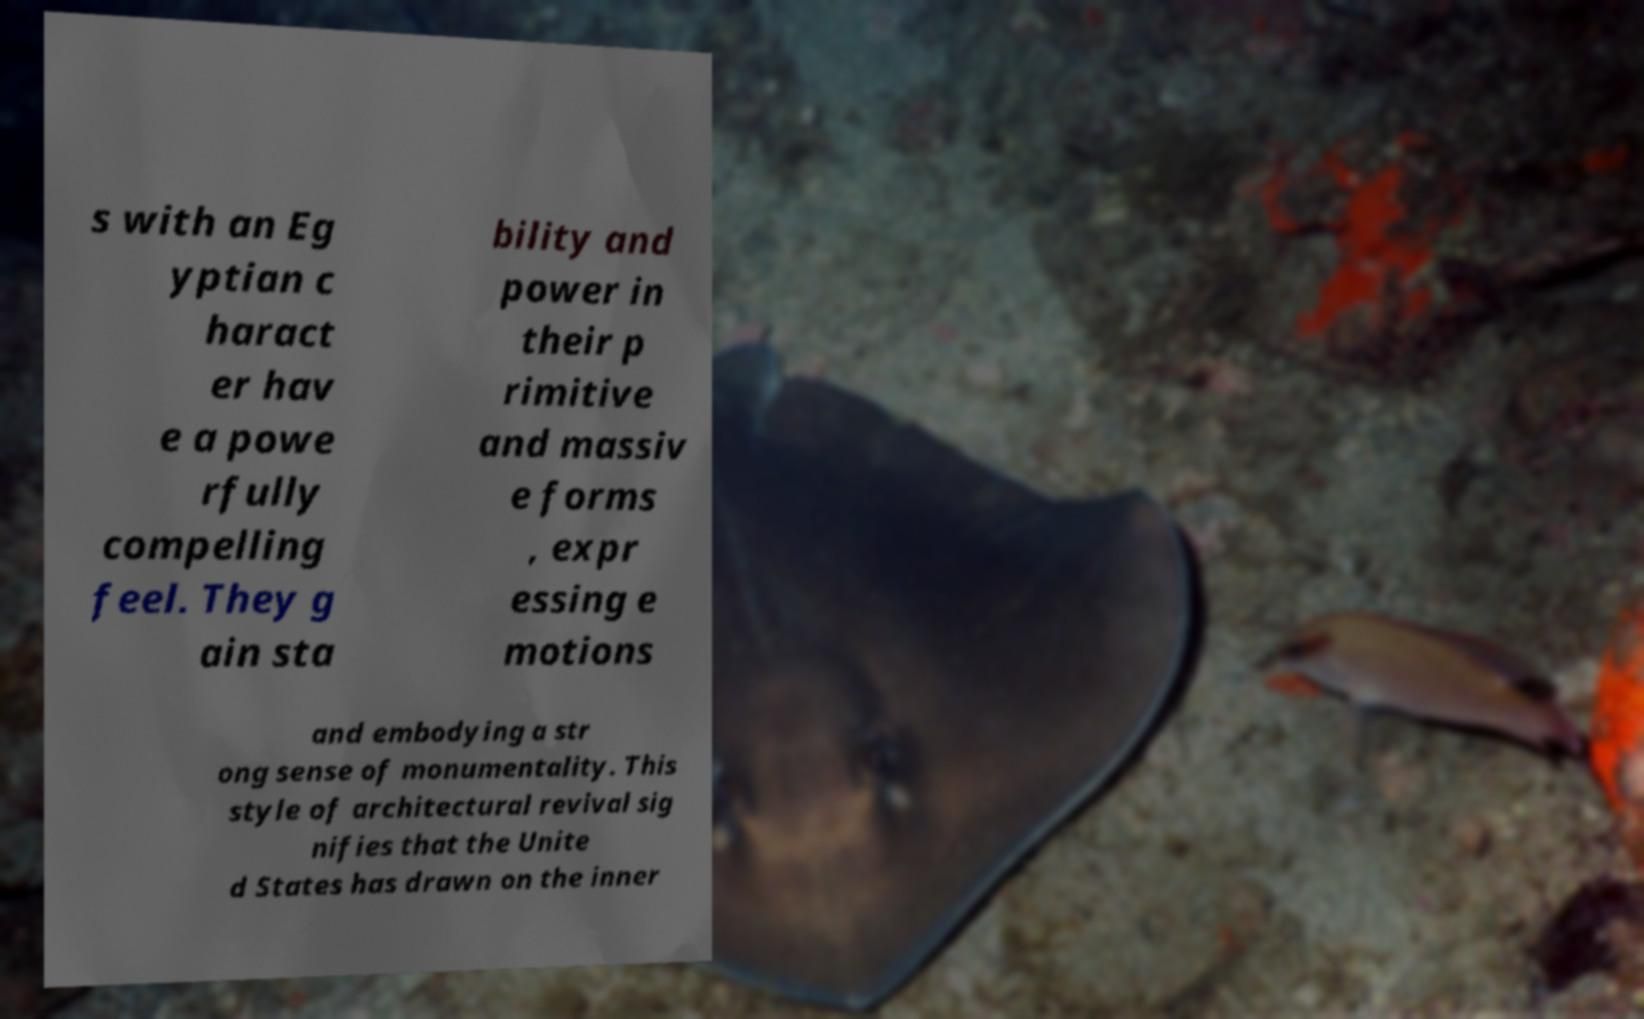Please identify and transcribe the text found in this image. s with an Eg yptian c haract er hav e a powe rfully compelling feel. They g ain sta bility and power in their p rimitive and massiv e forms , expr essing e motions and embodying a str ong sense of monumentality. This style of architectural revival sig nifies that the Unite d States has drawn on the inner 